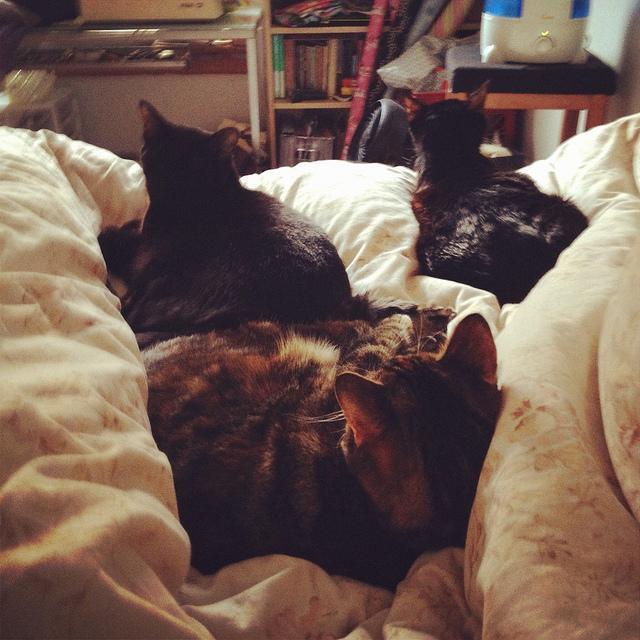What air quality problem occurs in this bedroom?
Pick the correct solution from the four options below to address the question.
Options: Mold, pollen, low humidity, high humidity. Low humidity. 